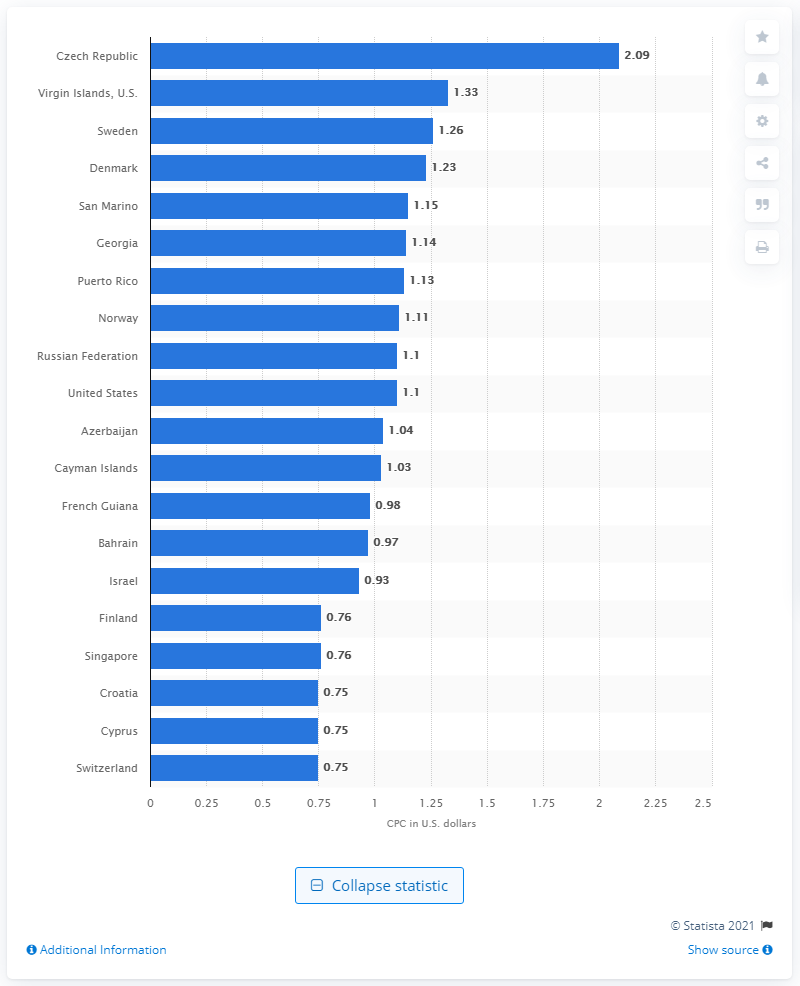List a handful of essential elements in this visual. The country with the highest cost-per-click on Facebook was the Czech Republic. 